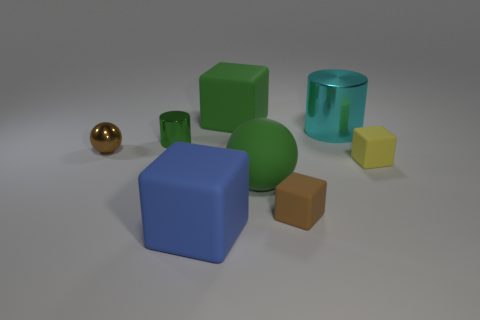There is another rubber thing that is the same size as the yellow rubber object; what shape is it?
Your answer should be very brief. Cube. There is a small matte cube left of the large cyan metal cylinder; how many small objects are to the right of it?
Your response must be concise. 1. Does the tiny metallic cylinder have the same color as the big cylinder?
Your answer should be very brief. No. How many other things are there of the same material as the small yellow thing?
Offer a very short reply. 4. There is a large thing on the left side of the large matte block that is behind the large green ball; what is its shape?
Provide a short and direct response. Cube. There is a matte block that is left of the green matte block; how big is it?
Give a very brief answer. Large. Are the cyan object and the brown cube made of the same material?
Your response must be concise. No. There is a green object that is the same material as the cyan cylinder; what shape is it?
Give a very brief answer. Cylinder. Is there any other thing that is the same color as the large matte ball?
Keep it short and to the point. Yes. What color is the small rubber thing that is in front of the tiny yellow block?
Offer a terse response. Brown. 